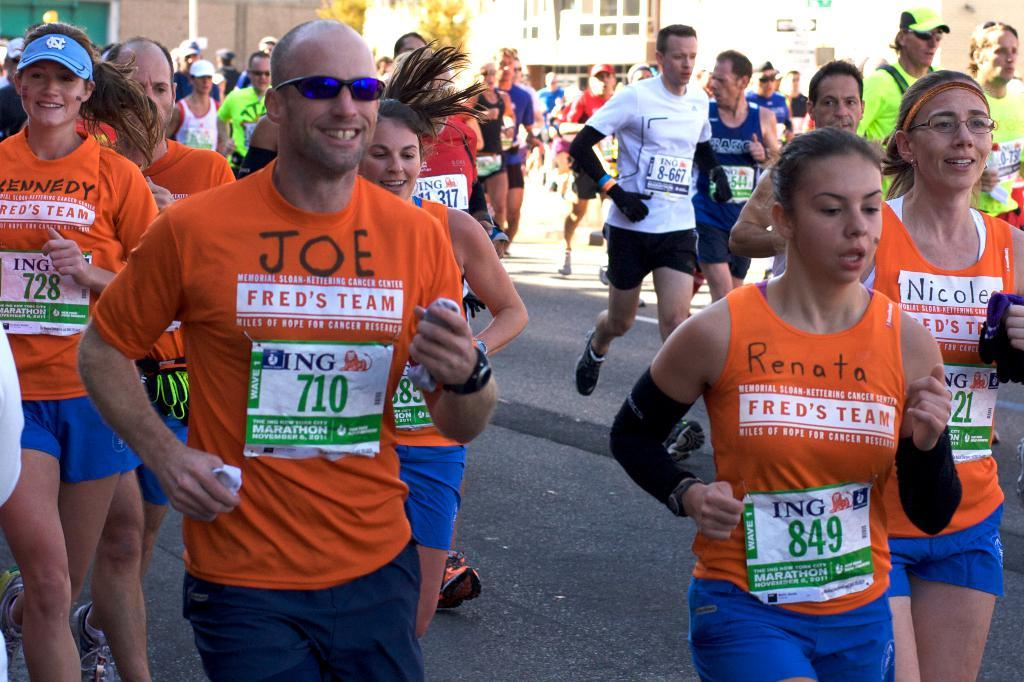What are the people in the image doing? There are many people running on the road in the image. What can be seen in the distance behind the people? There are buildings and trees in the background of the image. Where is the crib located in the image? There is no crib present in the image. What type of glove is being worn by the people running in the image? The image does not show any gloves being worn by the people running. 